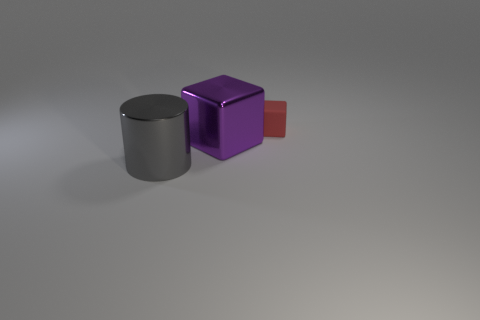How many other objects are there of the same size as the purple shiny object?
Provide a succinct answer. 1. Are the gray object and the cube that is behind the large purple block made of the same material?
Your answer should be compact. No. Are there fewer small blue matte cylinders than tiny red matte blocks?
Provide a short and direct response. Yes. Is there any other thing that has the same color as the matte object?
Offer a terse response. No. There is a big object that is the same material as the gray cylinder; what shape is it?
Offer a terse response. Cube. There is a cube left of the block that is behind the large purple object; what number of metallic things are to the left of it?
Provide a short and direct response. 1. The object that is both right of the gray thing and in front of the small red matte cube has what shape?
Keep it short and to the point. Cube. Is the number of red objects that are in front of the shiny cylinder less than the number of purple metallic objects?
Offer a terse response. Yes. What number of large objects are red rubber blocks or cylinders?
Ensure brevity in your answer.  1. How big is the cylinder?
Provide a succinct answer. Large. 